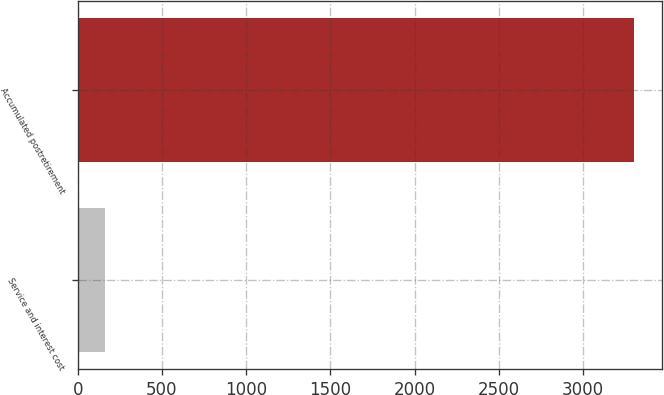Convert chart to OTSL. <chart><loc_0><loc_0><loc_500><loc_500><bar_chart><fcel>Service and interest cost<fcel>Accumulated postretirement<nl><fcel>165<fcel>3303<nl></chart> 